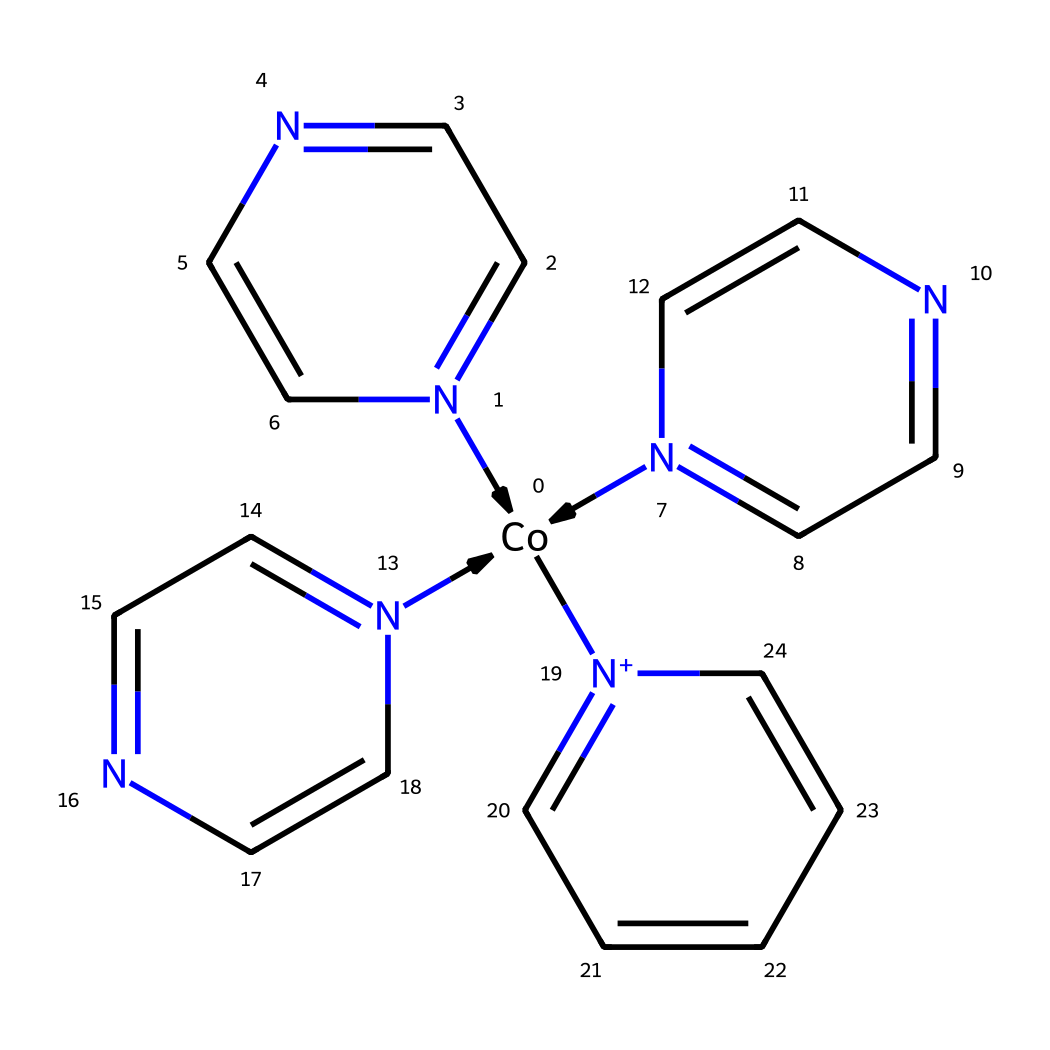What is the central metal ion in this coordination compound? The structure includes a cobalt atom indicated by the [Co] notation at the beginning of the SMILES representation. This confirms that cobalt is the central metal ion coordinating with the surrounding ligands.
Answer: cobalt How many nitrogen atoms are present in the coordination compound? By analyzing the SMILES, we see that there are five nitrogen atoms: three are part of the N-heterocyclic rings and one is in the positively charged group, along with one on the central cobalt. Each "N" or nitrogen in the structure indicates a nitrogen atom present in the molecule.
Answer: five What type of coordination does this cobalt complex exhibit? The presence of multiple nitrogen-containing heterocycles suggests that the cobalt has a high coordination number, typically four to six. The rings indicate a bidentate or tridentate coordination style due to the connectivity of the nitrogen atoms.
Answer: bidentate Does this compound exhibit spin crossover behavior? The presence of cobalt and its coordination with multiple nitrogen ligands corresponds to the characteristics typically associated with spin crossover complexes, where electronic configuration changes upon different conditions.
Answer: yes What type of ligands are coordinating to the cobalt center? The structure contains nitrogen atoms within aromatic rings, indicating that the ligands are neutral (non-charged) and are likely bidentate ligands, which are typical in coordination chemistry that allows for spin crossover phenomena.
Answer: neutral bidentate ligands How many aromatic rings are incorporated into the structure? The SMILES notation shows three distinct N-heterocyclic rings, and these are identified by the numbered indices in the nitrogen and carbon chain making the compound. Each cycle has aromatic character due to conjugation.
Answer: three 